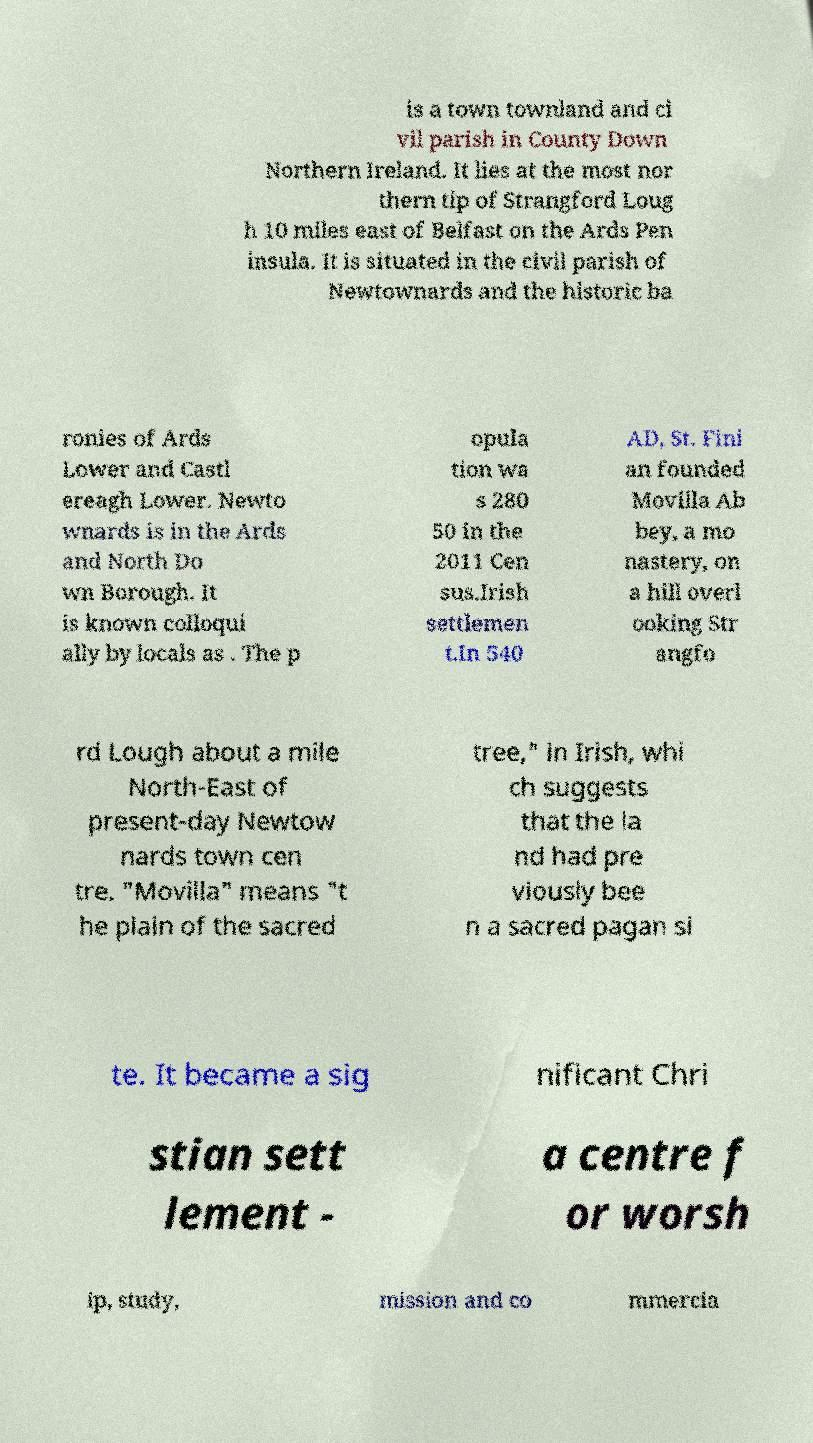Can you read and provide the text displayed in the image?This photo seems to have some interesting text. Can you extract and type it out for me? is a town townland and ci vil parish in County Down Northern Ireland. It lies at the most nor thern tip of Strangford Loug h 10 miles east of Belfast on the Ards Pen insula. It is situated in the civil parish of Newtownards and the historic ba ronies of Ards Lower and Castl ereagh Lower. Newto wnards is in the Ards and North Do wn Borough. It is known colloqui ally by locals as . The p opula tion wa s 280 50 in the 2011 Cen sus.Irish settlemen t.In 540 AD, St. Fini an founded Movilla Ab bey, a mo nastery, on a hill overl ooking Str angfo rd Lough about a mile North-East of present-day Newtow nards town cen tre. "Movilla" means "t he plain of the sacred tree," in Irish, whi ch suggests that the la nd had pre viously bee n a sacred pagan si te. It became a sig nificant Chri stian sett lement - a centre f or worsh ip, study, mission and co mmercia 